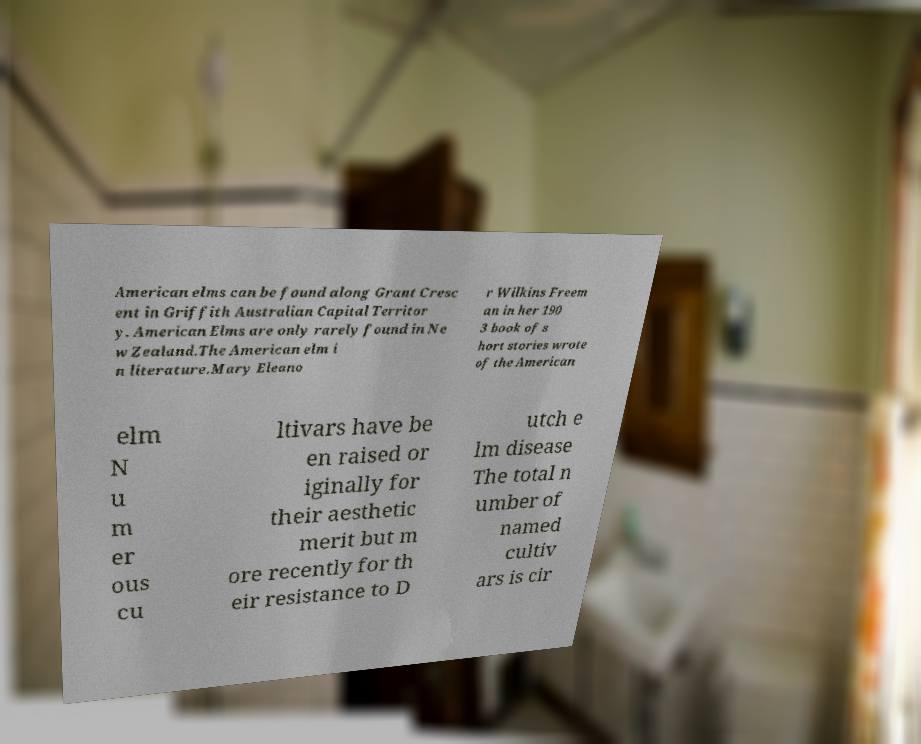What messages or text are displayed in this image? I need them in a readable, typed format. American elms can be found along Grant Cresc ent in Griffith Australian Capital Territor y. American Elms are only rarely found in Ne w Zealand.The American elm i n literature.Mary Eleano r Wilkins Freem an in her 190 3 book of s hort stories wrote of the American elm N u m er ous cu ltivars have be en raised or iginally for their aesthetic merit but m ore recently for th eir resistance to D utch e lm disease The total n umber of named cultiv ars is cir 